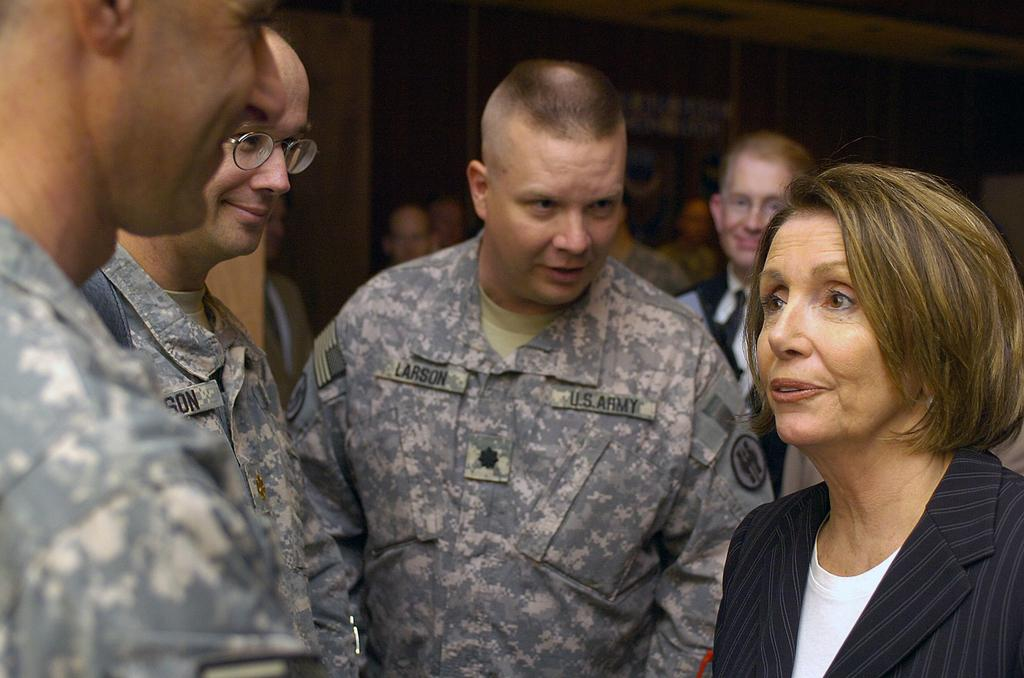How many people are in the image? There are people in the image, but the exact number is not specified. What are the people doing in the image? The people are interacting with each other in the image. What type of jelly is being used to create the doll in the image? There is no jelly or doll present in the image; it only shows people interacting with each other. 